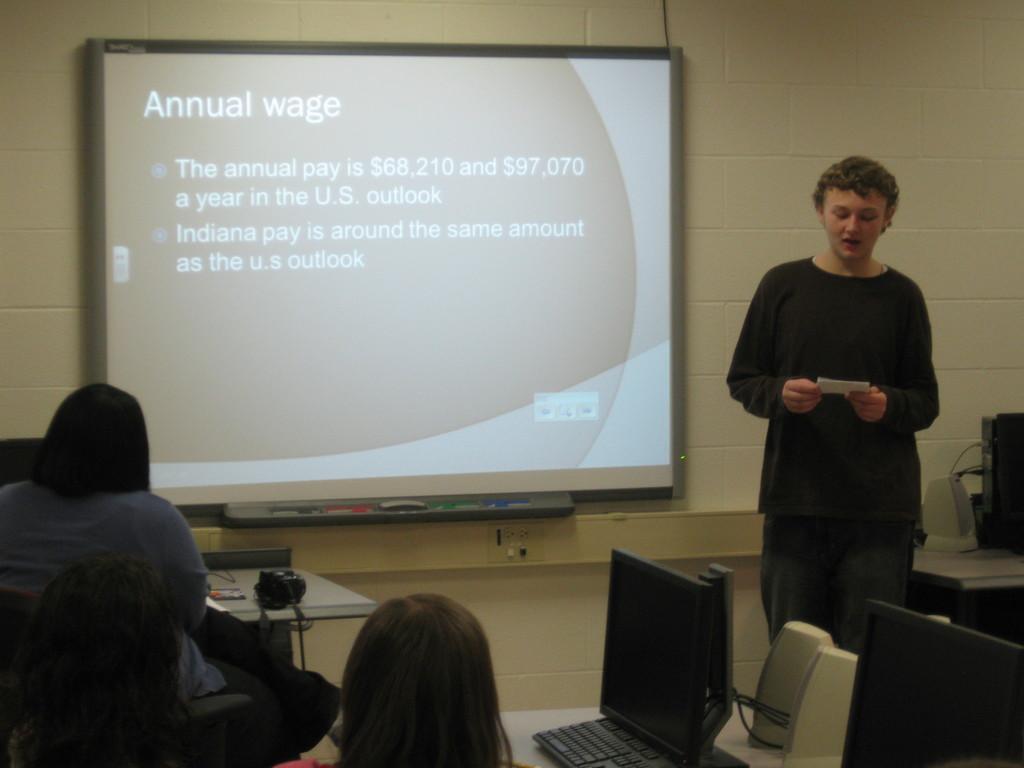Could you give a brief overview of what you see in this image? In this image we can see a person standing and holding something in the hand. There are few people sitting. There are tables. On the tables there is camera, computers, keyboard and few other things. In the back there is a wall with a screen. Near to the screen there are markers and a duster. 